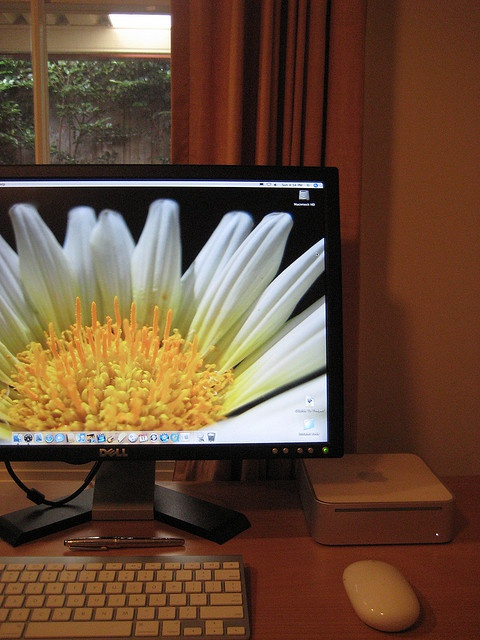Describe the objects in this image and their specific colors. I can see tv in maroon, black, lightgray, darkgray, and olive tones, keyboard in maroon, brown, and black tones, and mouse in maroon, brown, and black tones in this image. 